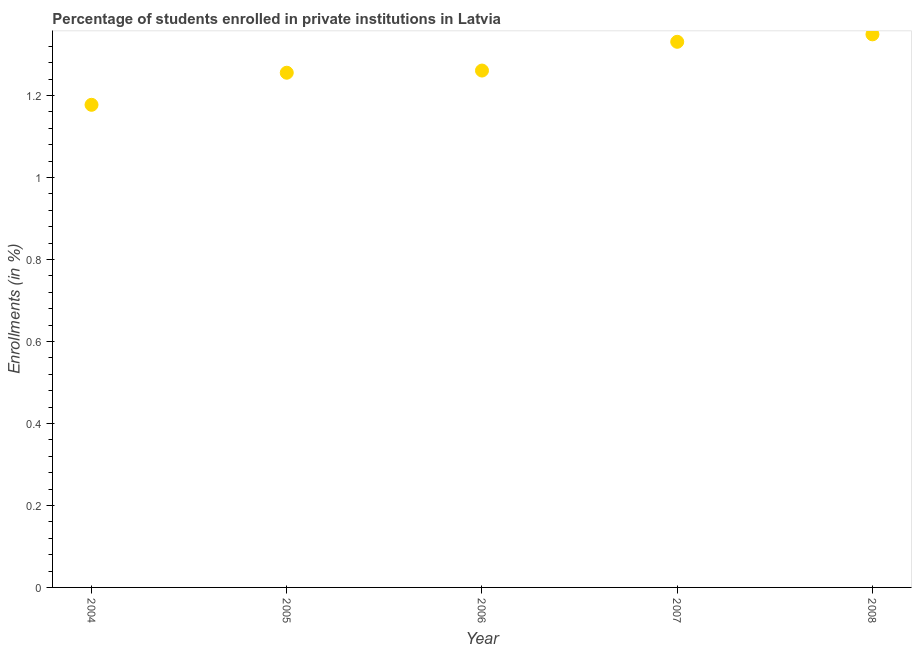What is the enrollments in private institutions in 2006?
Give a very brief answer. 1.26. Across all years, what is the maximum enrollments in private institutions?
Your answer should be compact. 1.35. Across all years, what is the minimum enrollments in private institutions?
Provide a short and direct response. 1.18. In which year was the enrollments in private institutions minimum?
Your answer should be compact. 2004. What is the sum of the enrollments in private institutions?
Your answer should be compact. 6.37. What is the difference between the enrollments in private institutions in 2004 and 2006?
Provide a short and direct response. -0.08. What is the average enrollments in private institutions per year?
Make the answer very short. 1.27. What is the median enrollments in private institutions?
Offer a very short reply. 1.26. What is the ratio of the enrollments in private institutions in 2004 to that in 2005?
Offer a terse response. 0.94. What is the difference between the highest and the second highest enrollments in private institutions?
Your response must be concise. 0.02. What is the difference between the highest and the lowest enrollments in private institutions?
Your response must be concise. 0.17. In how many years, is the enrollments in private institutions greater than the average enrollments in private institutions taken over all years?
Your answer should be very brief. 2. Does the enrollments in private institutions monotonically increase over the years?
Your answer should be compact. Yes. Are the values on the major ticks of Y-axis written in scientific E-notation?
Provide a succinct answer. No. Does the graph contain any zero values?
Keep it short and to the point. No. What is the title of the graph?
Offer a very short reply. Percentage of students enrolled in private institutions in Latvia. What is the label or title of the Y-axis?
Offer a very short reply. Enrollments (in %). What is the Enrollments (in %) in 2004?
Provide a succinct answer. 1.18. What is the Enrollments (in %) in 2005?
Your answer should be very brief. 1.26. What is the Enrollments (in %) in 2006?
Give a very brief answer. 1.26. What is the Enrollments (in %) in 2007?
Provide a short and direct response. 1.33. What is the Enrollments (in %) in 2008?
Offer a very short reply. 1.35. What is the difference between the Enrollments (in %) in 2004 and 2005?
Your response must be concise. -0.08. What is the difference between the Enrollments (in %) in 2004 and 2006?
Your response must be concise. -0.08. What is the difference between the Enrollments (in %) in 2004 and 2007?
Your answer should be compact. -0.15. What is the difference between the Enrollments (in %) in 2004 and 2008?
Offer a terse response. -0.17. What is the difference between the Enrollments (in %) in 2005 and 2006?
Provide a succinct answer. -0.01. What is the difference between the Enrollments (in %) in 2005 and 2007?
Offer a very short reply. -0.08. What is the difference between the Enrollments (in %) in 2005 and 2008?
Offer a terse response. -0.09. What is the difference between the Enrollments (in %) in 2006 and 2007?
Provide a succinct answer. -0.07. What is the difference between the Enrollments (in %) in 2006 and 2008?
Give a very brief answer. -0.09. What is the difference between the Enrollments (in %) in 2007 and 2008?
Ensure brevity in your answer.  -0.02. What is the ratio of the Enrollments (in %) in 2004 to that in 2005?
Offer a very short reply. 0.94. What is the ratio of the Enrollments (in %) in 2004 to that in 2006?
Provide a succinct answer. 0.93. What is the ratio of the Enrollments (in %) in 2004 to that in 2007?
Give a very brief answer. 0.89. What is the ratio of the Enrollments (in %) in 2004 to that in 2008?
Your answer should be compact. 0.87. What is the ratio of the Enrollments (in %) in 2005 to that in 2007?
Your answer should be very brief. 0.94. What is the ratio of the Enrollments (in %) in 2005 to that in 2008?
Your answer should be very brief. 0.93. What is the ratio of the Enrollments (in %) in 2006 to that in 2007?
Offer a very short reply. 0.95. What is the ratio of the Enrollments (in %) in 2006 to that in 2008?
Provide a short and direct response. 0.94. What is the ratio of the Enrollments (in %) in 2007 to that in 2008?
Offer a terse response. 0.99. 